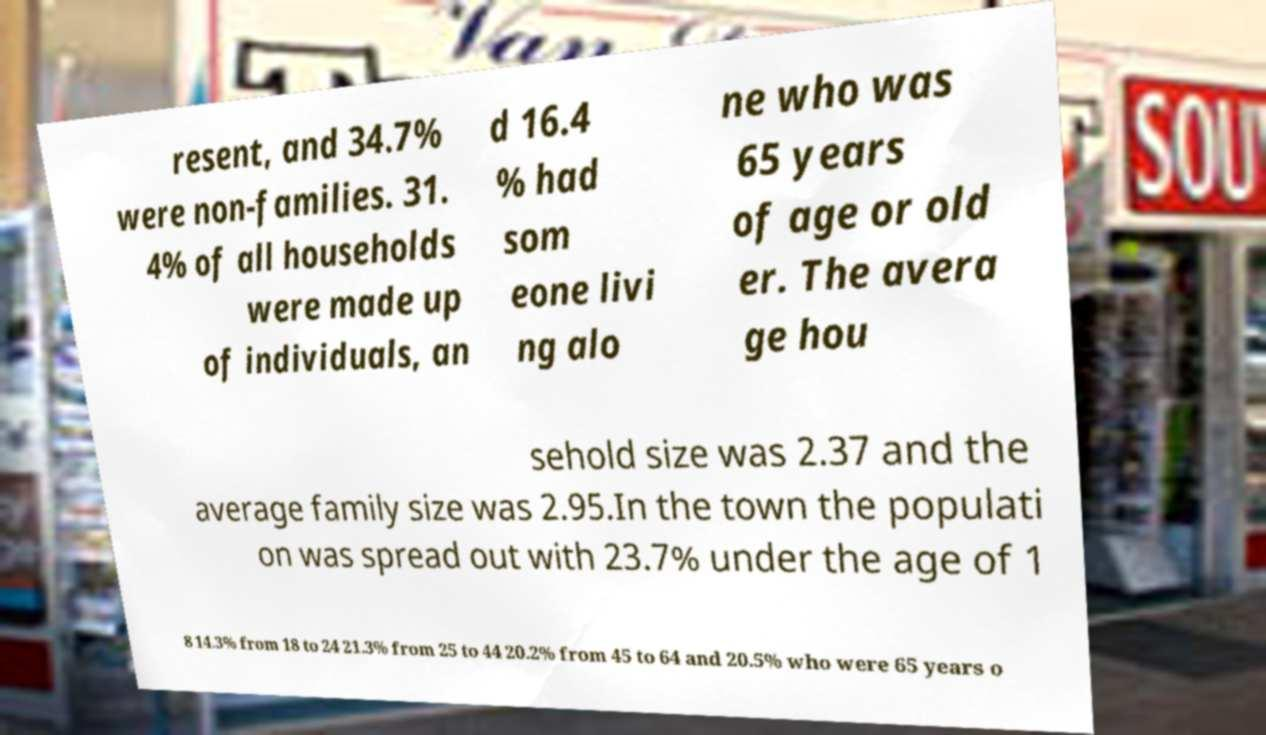Please identify and transcribe the text found in this image. resent, and 34.7% were non-families. 31. 4% of all households were made up of individuals, an d 16.4 % had som eone livi ng alo ne who was 65 years of age or old er. The avera ge hou sehold size was 2.37 and the average family size was 2.95.In the town the populati on was spread out with 23.7% under the age of 1 8 14.3% from 18 to 24 21.3% from 25 to 44 20.2% from 45 to 64 and 20.5% who were 65 years o 